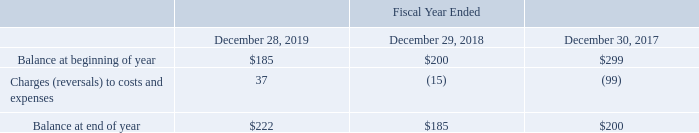Accounts Receivable and Allowance for Doubtful Accounts
The majority of our accounts receivable are derived from sales to large multinational semiconductor manufacturers throughout the world, are recorded at their invoiced amount and do not bear interest.
In order to monitor potential credit losses, we perform ongoing credit evaluations of our customers' financial condition. An allowance for doubtful accounts is maintained based upon our assessment of the expected collectability of all accounts receivable. The allowance for doubtful accounts is reviewed and assessed for adequacy on a quarterly basis.
We take into consideration (1) any circumstances of which we are aware of a customer's inability to meet its financial obligations and (2) our judgments as to prevailing economic conditions in the industry and their impact on our customers. If circumstances change, and the financial condition of our customers is adversely affected and they are unable to meet their financial obligations, we may need to take additional allowances, which would result in an increase in our operating expense.
Activity related to our allowance for doubtful accounts receivable was as follows (in thousands):
What is the main source of accounts receivable? Derived from sales to large multinational semiconductor manufacturers throughout the world. What is the change in allowance Balance at beginning of year from Fiscal Year Ended December 28, 2019 to December 29, 2018?
Answer scale should be: thousand. 185-200
Answer: -15. What is the change in allowance Charges (reversals) to costs and expenses from Fiscal Year Ended December 28, 2019 to December 29, 2018?
Answer scale should be: thousand. 37-(15)
Answer: 52. In which year was Balance at beginning of year less than 200 thousands? Locate and analyze balance at beginning of year in row 3
answer: 2019. What was the Charges (reversals) to costs and expenses in 2019, 2018 and 2017 respectively?
Answer scale should be: thousand. 37, (15), (99). How does the company monitor the potential credit loss? We perform ongoing credit evaluations of our customers' financial condition. 